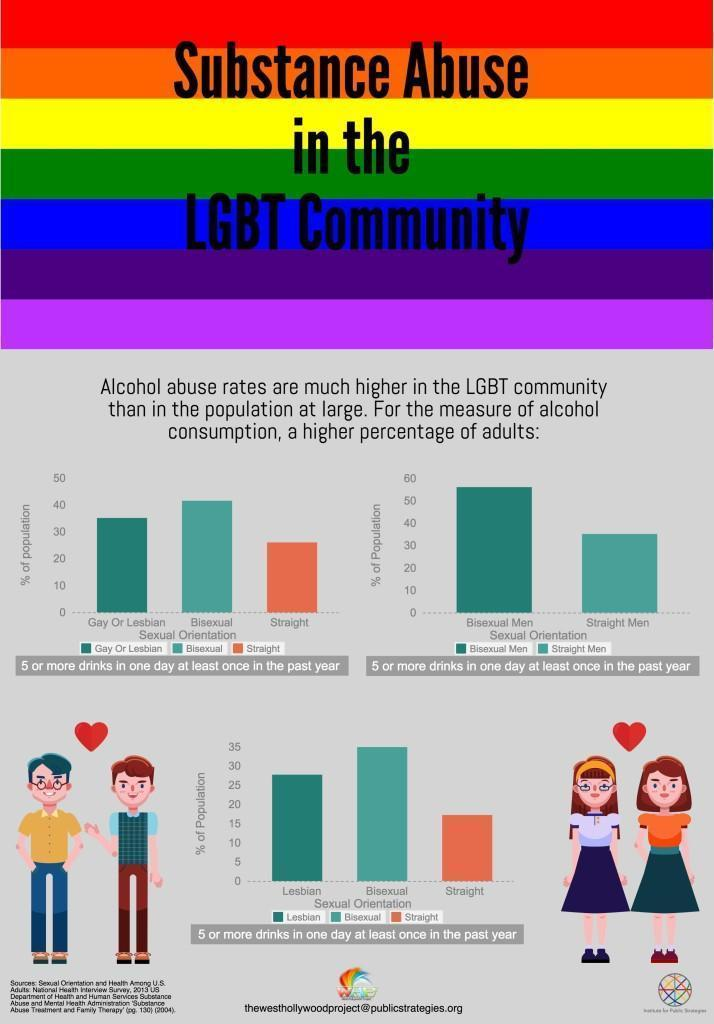Alcohol consumption is higher in which group of people - Bisexual or Straight?
Answer the question with a short phrase. Bisexual 